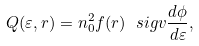Convert formula to latex. <formula><loc_0><loc_0><loc_500><loc_500>Q ( \varepsilon , r ) = n _ { 0 } ^ { 2 } f ( r ) \ s i g v \frac { d \phi } { d \varepsilon } ,</formula> 